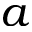Convert formula to latex. <formula><loc_0><loc_0><loc_500><loc_500>a</formula> 